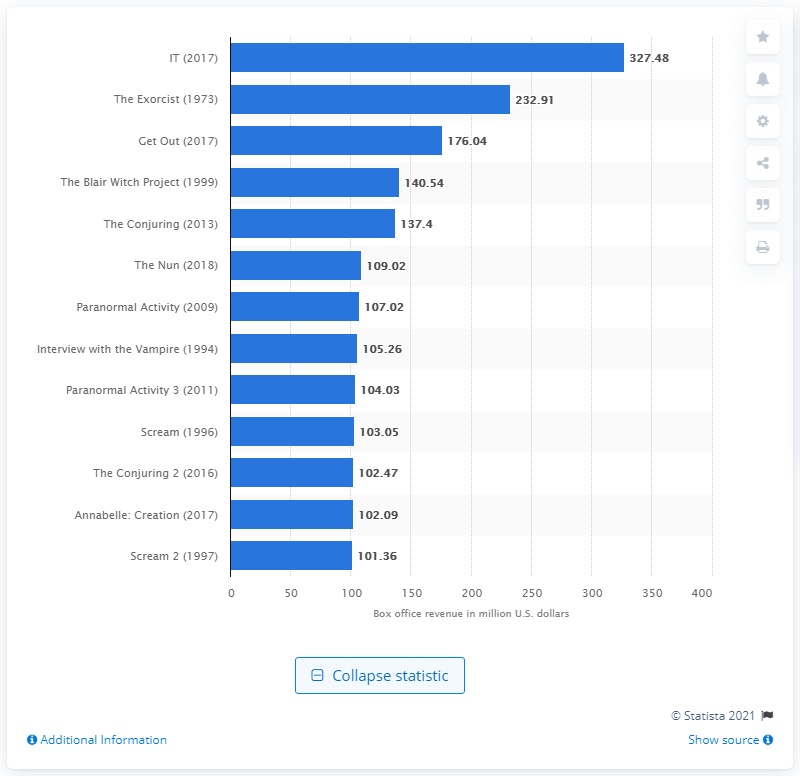Highlight a few significant elements in this photo. From September 2017 to October 2018, the box office revenue generated by "IT" was 327.48 million. 